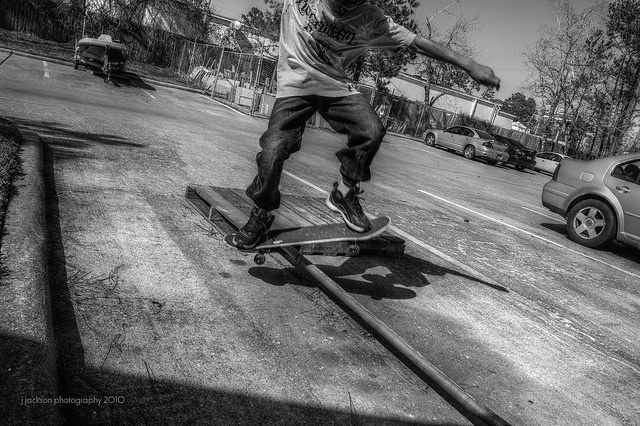Describe the objects in this image and their specific colors. I can see people in black, gray, darkgray, and lightgray tones, car in black, gray, and lightgray tones, skateboard in black, gray, darkgray, and lightgray tones, car in black, gray, and lightgray tones, and boat in black, gray, darkgray, and lightgray tones in this image. 